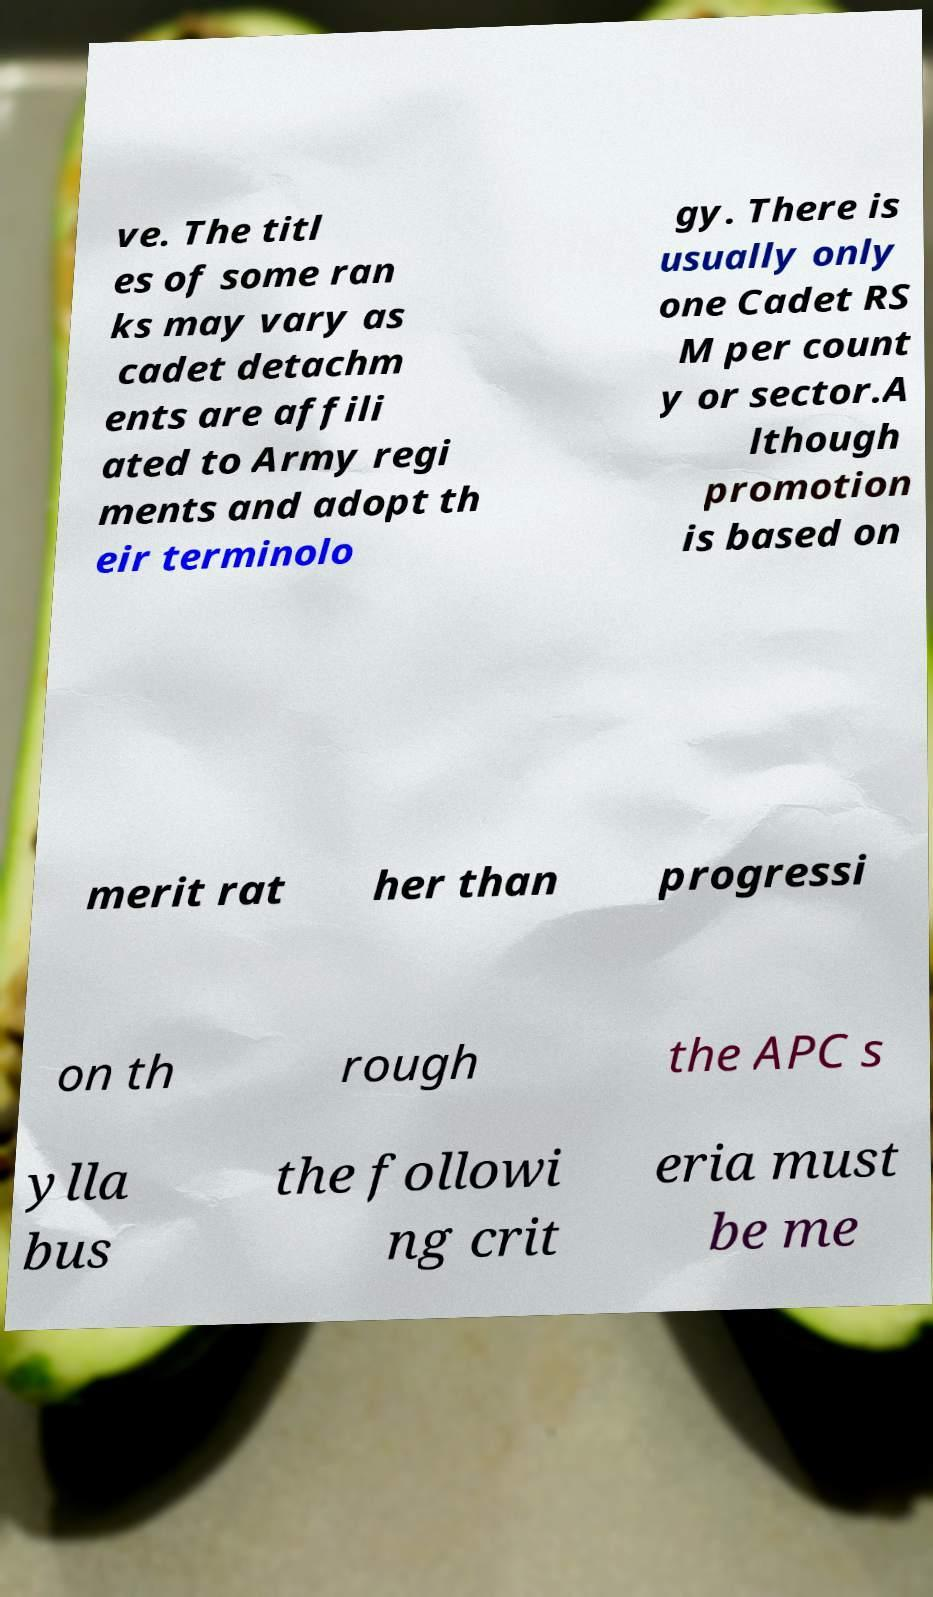Please identify and transcribe the text found in this image. ve. The titl es of some ran ks may vary as cadet detachm ents are affili ated to Army regi ments and adopt th eir terminolo gy. There is usually only one Cadet RS M per count y or sector.A lthough promotion is based on merit rat her than progressi on th rough the APC s ylla bus the followi ng crit eria must be me 